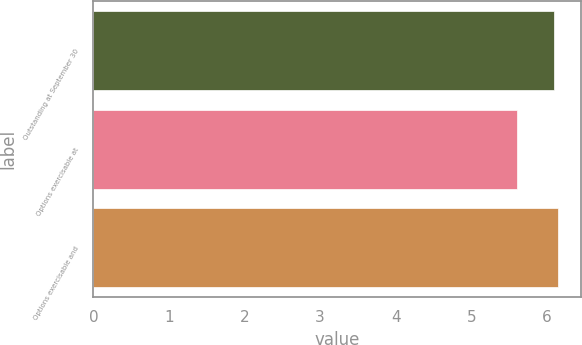Convert chart to OTSL. <chart><loc_0><loc_0><loc_500><loc_500><bar_chart><fcel>Outstanding at September 30<fcel>Options exercisable at<fcel>Options exercisable and<nl><fcel>6.1<fcel>5.6<fcel>6.15<nl></chart> 